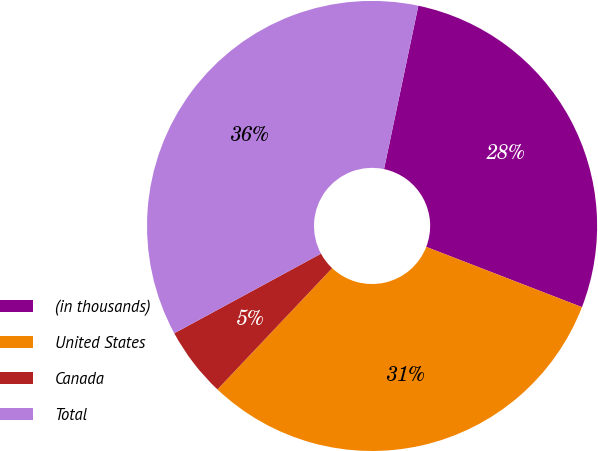Convert chart to OTSL. <chart><loc_0><loc_0><loc_500><loc_500><pie_chart><fcel>(in thousands)<fcel>United States<fcel>Canada<fcel>Total<nl><fcel>27.58%<fcel>31.18%<fcel>5.03%<fcel>36.21%<nl></chart> 